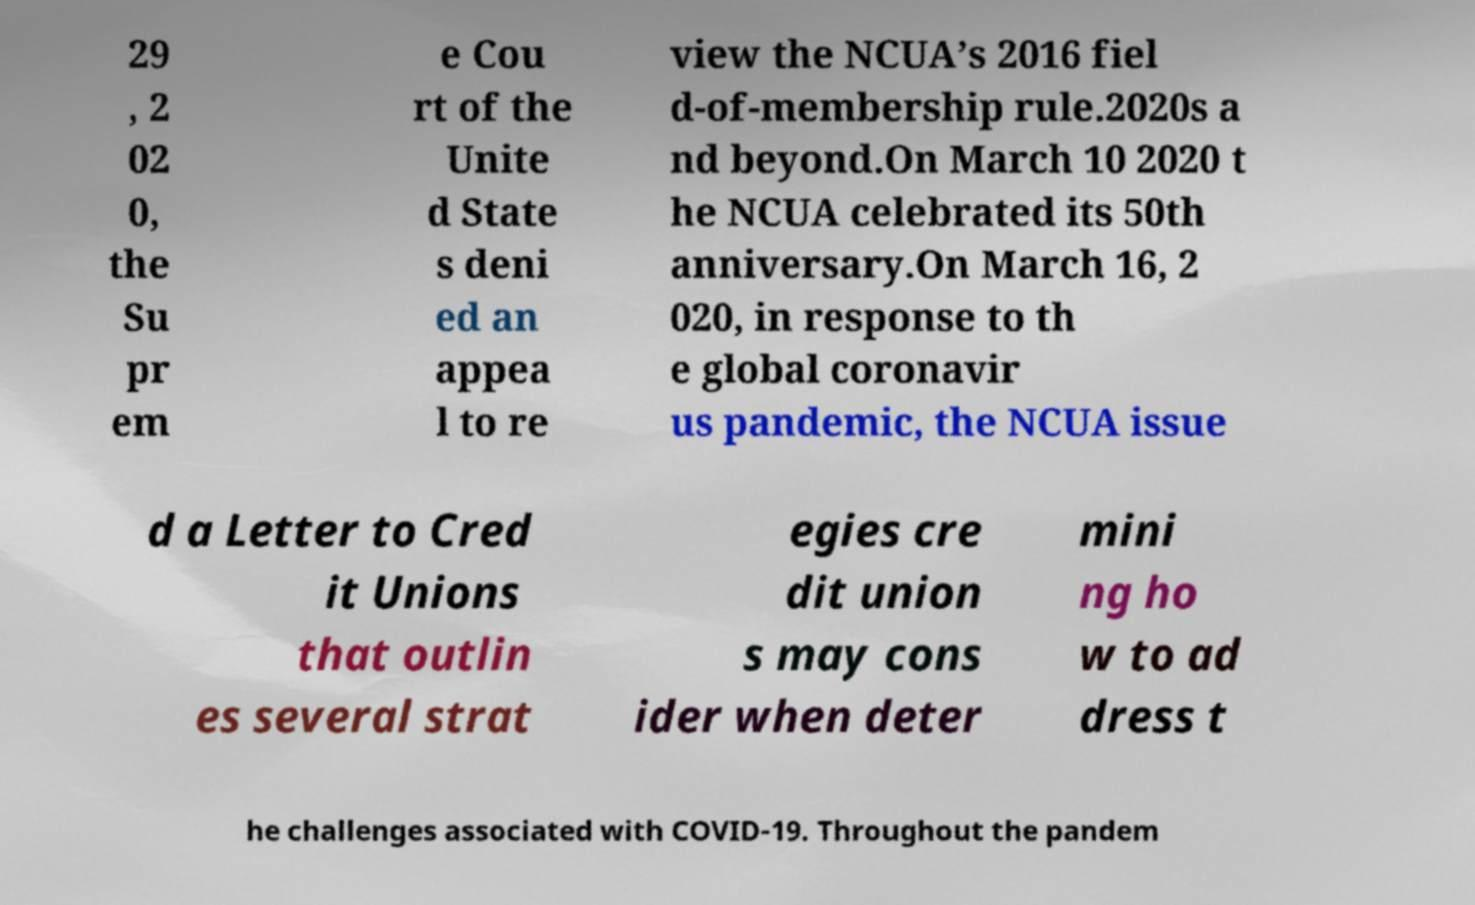There's text embedded in this image that I need extracted. Can you transcribe it verbatim? 29 , 2 02 0, the Su pr em e Cou rt of the Unite d State s deni ed an appea l to re view the NCUA’s 2016 fiel d-of-membership rule.2020s a nd beyond.On March 10 2020 t he NCUA celebrated its 50th anniversary.On March 16, 2 020, in response to th e global coronavir us pandemic, the NCUA issue d a Letter to Cred it Unions that outlin es several strat egies cre dit union s may cons ider when deter mini ng ho w to ad dress t he challenges associated with COVID-19. Throughout the pandem 